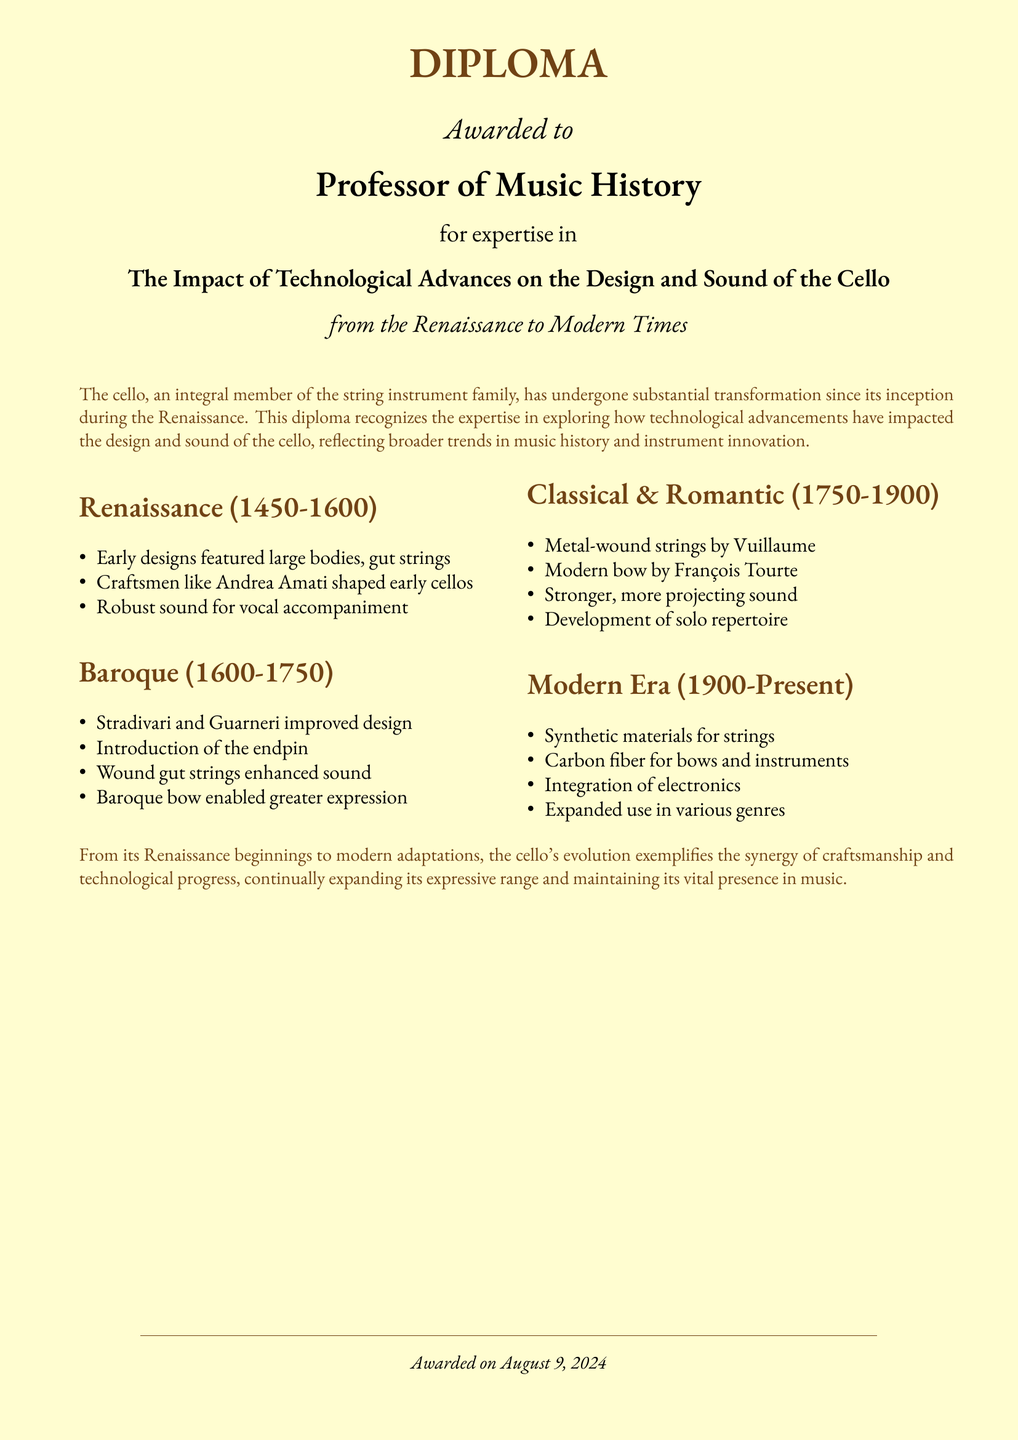What is the title of the diploma? The title of the diploma is found in the header, emphasizing the main subject matter.
Answer: The Impact of Technological Advances on the Design and Sound of the Cello Who is awarded this diploma? The recipient of the diploma is specified directly below the title.
Answer: Professor of Music History Which crafting period is associated with Andrea Amati? The section discussing early cello designs names Andrea Amati and his association with a specific period.
Answer: Renaissance What innovation did Stradivari and Guarneri bring to cello design? The Baroque period section highlights significant improvements made by notable craftsmen.
Answer: Improved design What material was used for strings in the Classical era? The Classical & Romantic section details a significant advancement in string materials during this time.
Answer: Metal-wound strings Which bow design was developed by François Tourte? The Classical & Romantic section attributes a specific bow design to François Tourte.
Answer: Modern bow What technology has been integrated into modern cellos? The Modern Era section outlines advancements in technology impacting the cello's design and sound.
Answer: Electronics What characteristic change did the introduction of synthetic materials lead to? The Modern Era section suggests an overall transformation resulting from the use of synthetic materials.
Answer: Expanded sound possibilities 